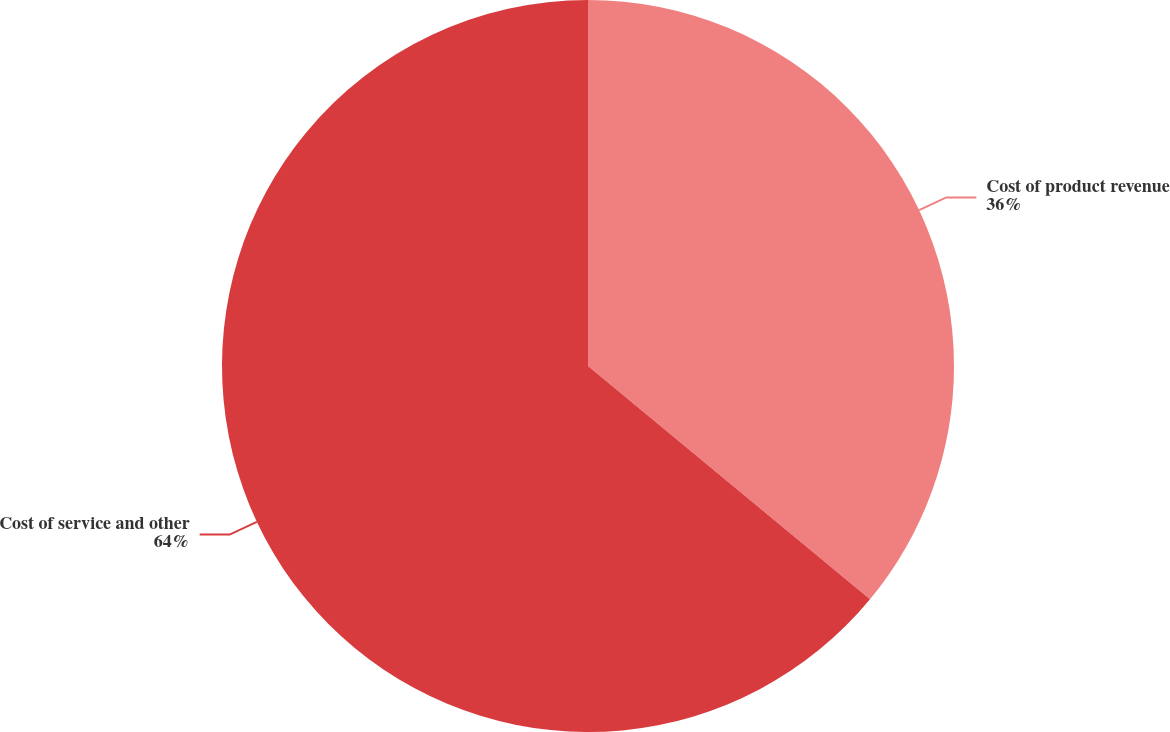<chart> <loc_0><loc_0><loc_500><loc_500><pie_chart><fcel>Cost of product revenue<fcel>Cost of service and other<nl><fcel>36.0%<fcel>64.0%<nl></chart> 